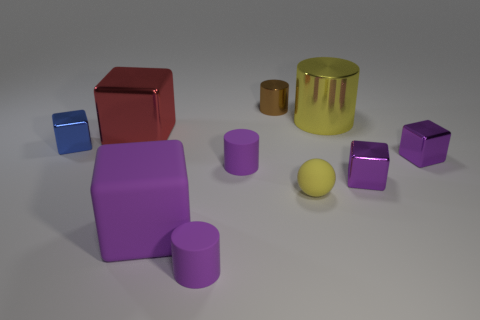Are there the same number of purple cubes on the left side of the brown cylinder and brown objects?
Make the answer very short. Yes. What number of tiny cylinders have the same color as the tiny matte ball?
Your answer should be compact. 0. There is a small shiny thing that is the same shape as the big yellow metallic thing; what is its color?
Your answer should be compact. Brown. Do the yellow matte sphere and the yellow metal thing have the same size?
Your response must be concise. No. Are there the same number of yellow cylinders in front of the yellow sphere and tiny purple matte cylinders behind the yellow metallic thing?
Offer a very short reply. Yes. Are there any big shiny things?
Your response must be concise. Yes. What is the size of the rubber object that is the same shape as the red metallic object?
Offer a very short reply. Large. How big is the red block that is to the left of the yellow cylinder?
Your answer should be very brief. Large. Are there more large yellow shiny cylinders that are in front of the yellow matte object than tiny brown cylinders?
Offer a terse response. No. What shape is the big yellow thing?
Ensure brevity in your answer.  Cylinder. 